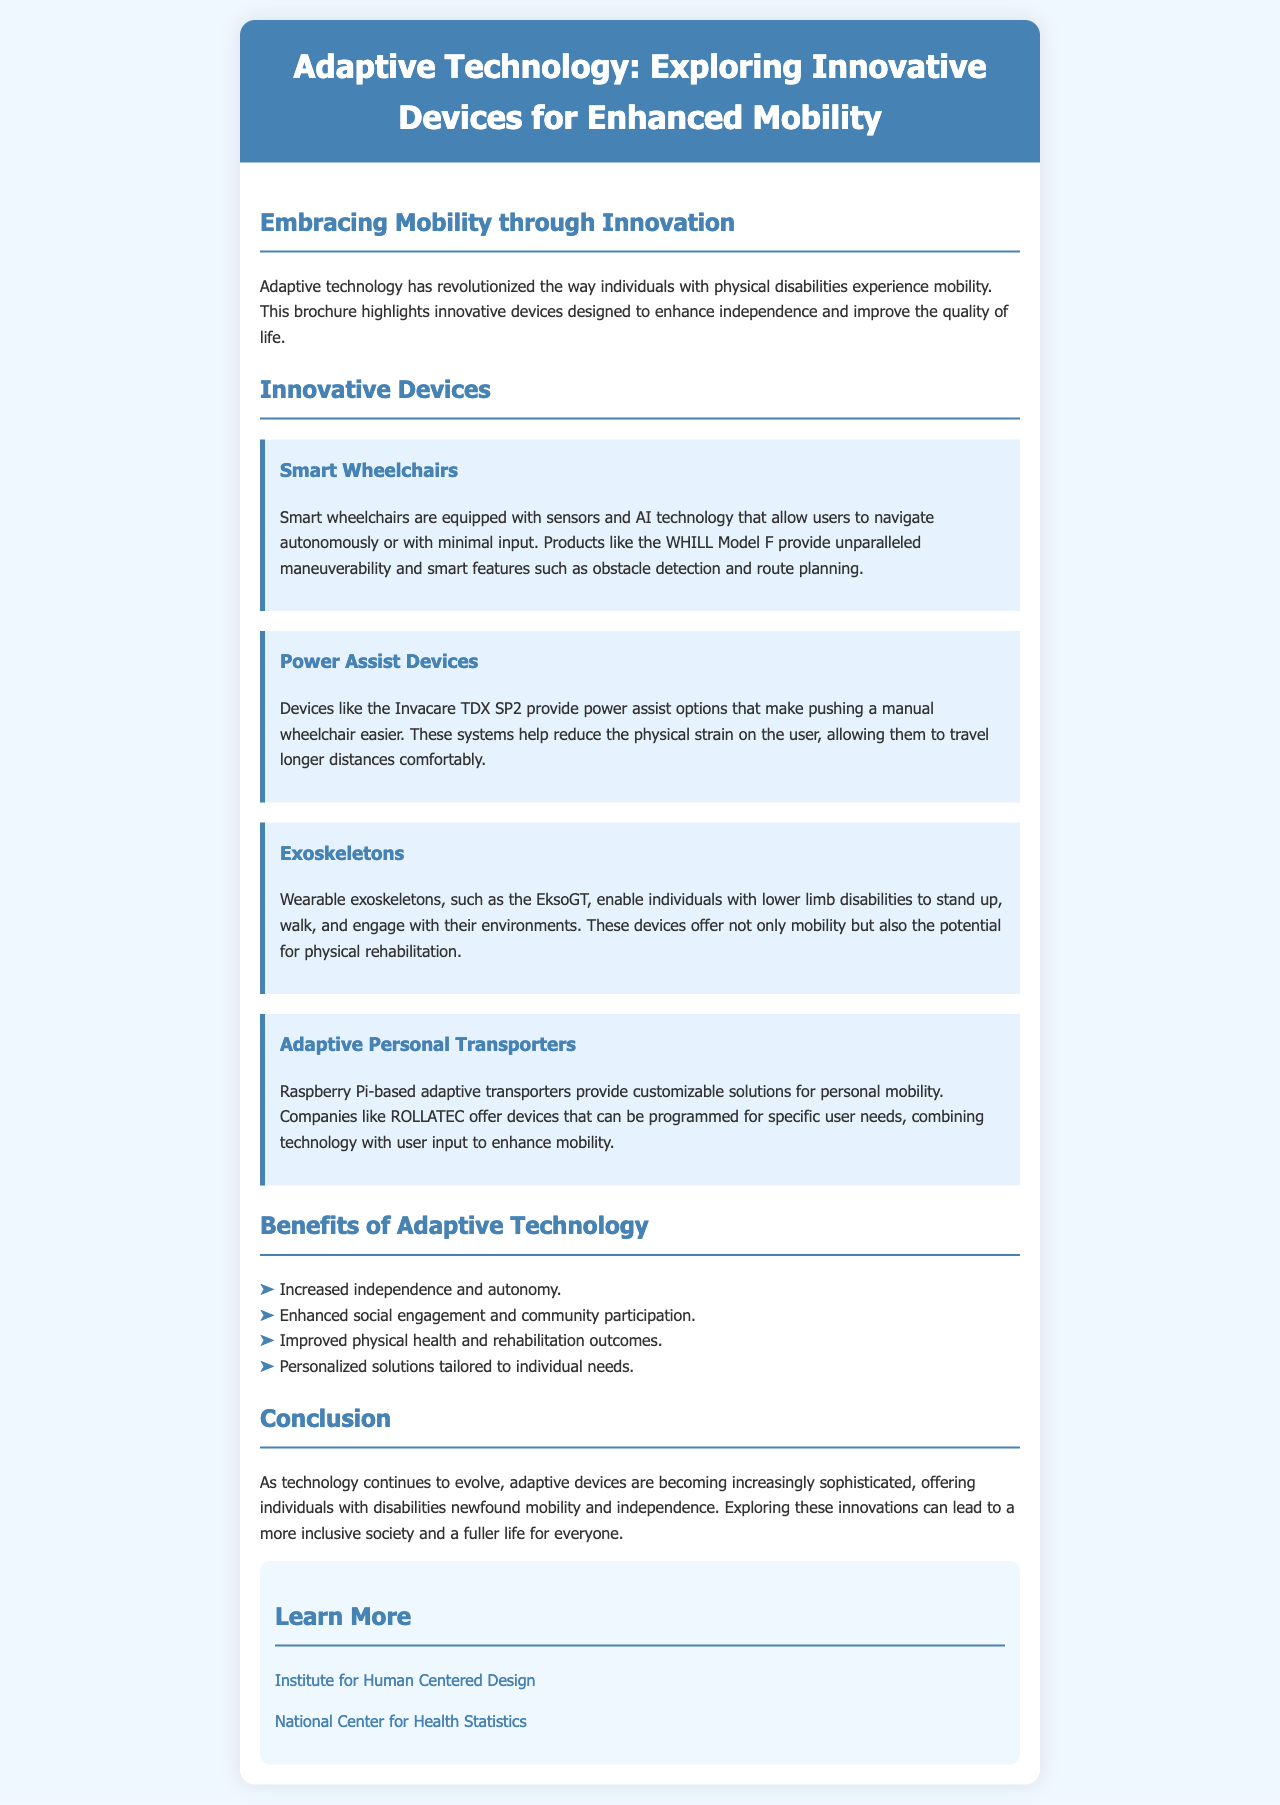What is the title of the brochure? The title of the brochure is stated prominently at the top of the document, summarizing its focus on adaptive technology.
Answer: Adaptive Technology: Exploring Innovative Devices for Enhanced Mobility What device allows users to navigate autonomously? The brochure mentions a specific type of wheelchair equipped with technology for autonomous navigation.
Answer: Smart Wheelchairs Which device helps users push their manual wheelchair with less effort? The brochure describes a category of devices that assist in reducing physical strain while using a manual wheelchair.
Answer: Power Assist Devices What is one of the benefits of adaptive technology listed in the document? The document outlines several benefits of adaptive technology, highlighting how it can positively impact individuals' lives.
Answer: Increased independence and autonomy Which company offers Raspberry Pi-based adaptive transporters? The document provides a specific company name associated with customizable transport solutions.
Answer: ROLLATEC What type of technology is the EksoGT? The brochure introduces a specific wearable device that supports mobility for individuals with lower limb disabilities.
Answer: Exoskeletons How does adaptive technology impact social engagement? The document explains the broader implications of adaptive technology on community participation and social interactions.
Answer: Enhanced social engagement and community participation What can be found in the "Learn More" section? The document includes linked resources that provide additional information about adaptive technology and related topics.
Answer: Resources and links for further learning 